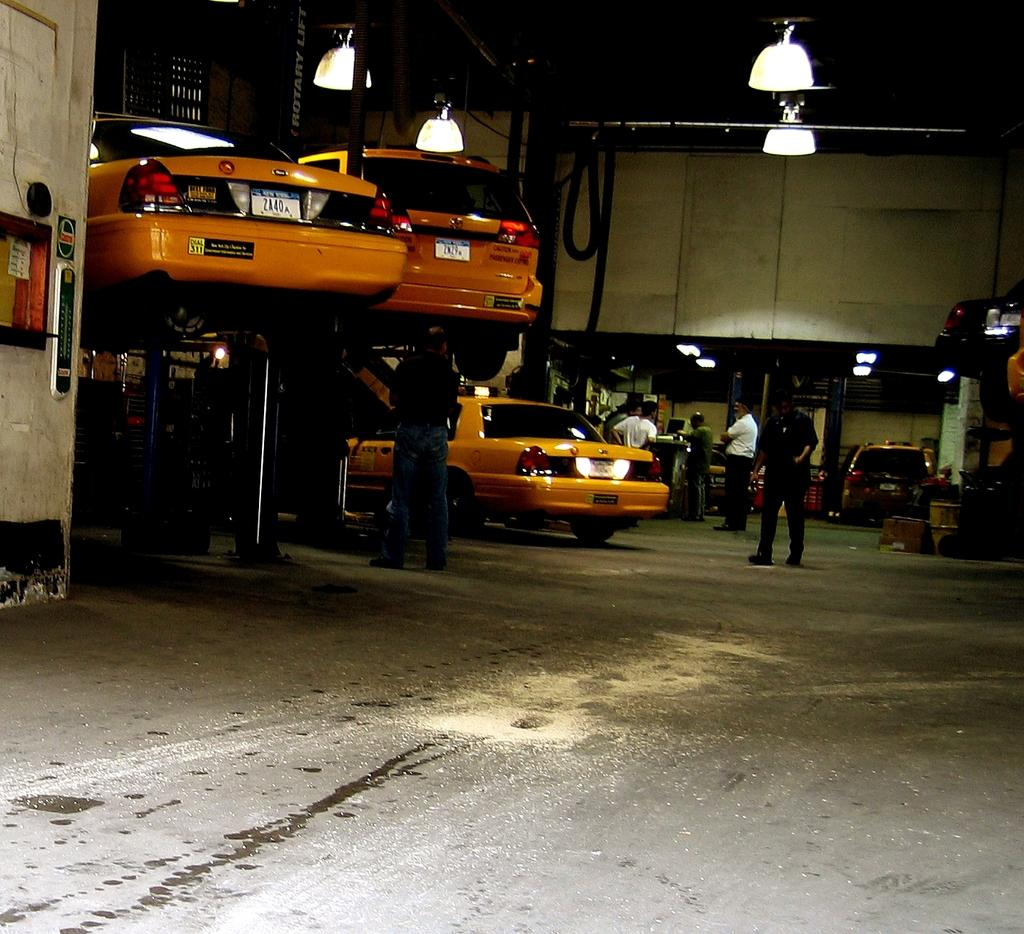What type of vehicles can be seen in the image? There are cars in the image. Are there any people present in the image? Yes, there are people standing in the image. What type of lighting is present in the image? There are lights hanging from the ceiling in the image. How are some of the cars positioned in the image? Some cars are lifted up in the image. What type of location does the image appear to depict? The image appears to depict a garage. What type of snow can be seen falling in the image? There is no snow present in the image; it depicts a garage with cars and people. 